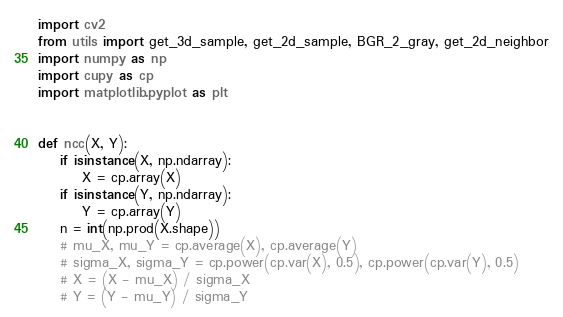Convert code to text. <code><loc_0><loc_0><loc_500><loc_500><_Python_>import cv2
from utils import get_3d_sample, get_2d_sample, BGR_2_gray, get_2d_neighbor
import numpy as np
import cupy as cp
import matplotlib.pyplot as plt


def ncc(X, Y):
    if isinstance(X, np.ndarray):
        X = cp.array(X)
    if isinstance(Y, np.ndarray):
        Y = cp.array(Y)
    n = int(np.prod(X.shape))
    # mu_X, mu_Y = cp.average(X), cp.average(Y)
    # sigma_X, sigma_Y = cp.power(cp.var(X), 0.5), cp.power(cp.var(Y), 0.5)
    # X = (X - mu_X) / sigma_X
    # Y = (Y - mu_Y) / sigma_Y</code> 